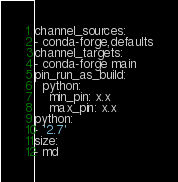Convert code to text. <code><loc_0><loc_0><loc_500><loc_500><_YAML_>channel_sources:
- conda-forge,defaults
channel_targets:
- conda-forge main
pin_run_as_build:
  python:
    min_pin: x.x
    max_pin: x.x
python:
- '2.7'
size:
- md
</code> 